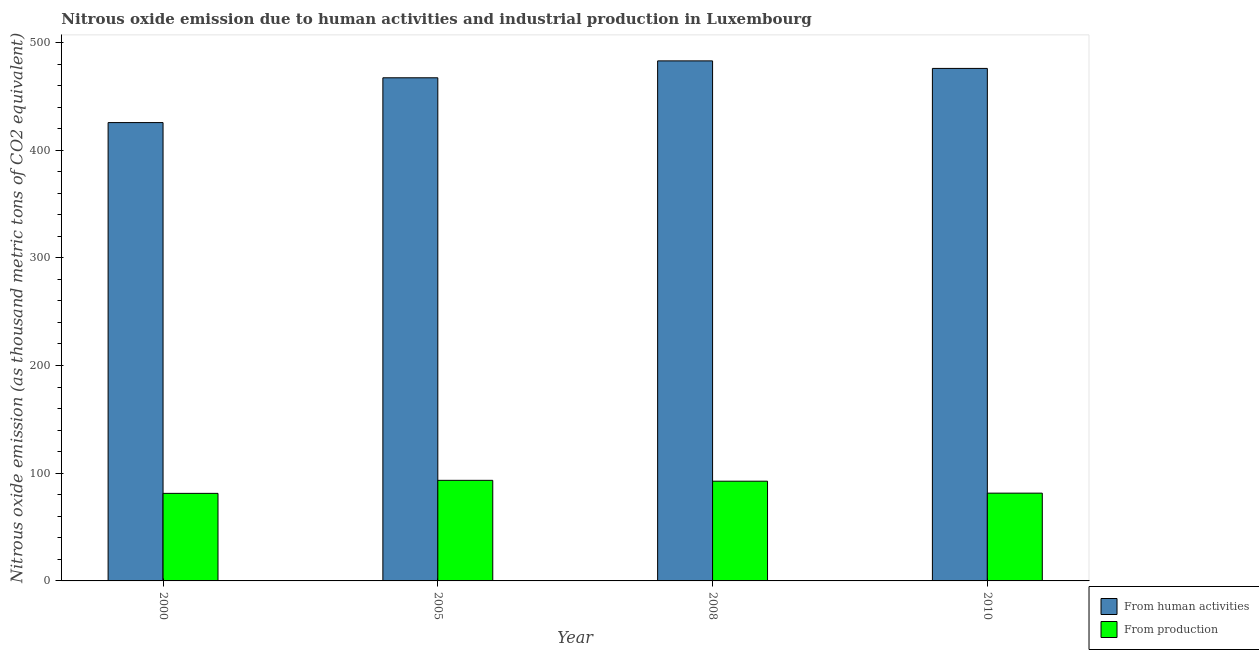How many groups of bars are there?
Provide a succinct answer. 4. How many bars are there on the 1st tick from the left?
Your answer should be very brief. 2. How many bars are there on the 1st tick from the right?
Your answer should be compact. 2. What is the label of the 1st group of bars from the left?
Give a very brief answer. 2000. In how many cases, is the number of bars for a given year not equal to the number of legend labels?
Your answer should be compact. 0. What is the amount of emissions generated from industries in 2005?
Provide a short and direct response. 93.4. Across all years, what is the maximum amount of emissions from human activities?
Your answer should be very brief. 482.9. Across all years, what is the minimum amount of emissions generated from industries?
Provide a succinct answer. 81.3. What is the total amount of emissions from human activities in the graph?
Offer a very short reply. 1851.6. What is the difference between the amount of emissions from human activities in 2000 and that in 2010?
Offer a very short reply. -50.3. What is the average amount of emissions generated from industries per year?
Make the answer very short. 87.2. What is the ratio of the amount of emissions generated from industries in 2008 to that in 2010?
Provide a short and direct response. 1.14. Is the amount of emissions from human activities in 2000 less than that in 2008?
Provide a short and direct response. Yes. Is the difference between the amount of emissions generated from industries in 2005 and 2008 greater than the difference between the amount of emissions from human activities in 2005 and 2008?
Ensure brevity in your answer.  No. What is the difference between the highest and the lowest amount of emissions generated from industries?
Offer a terse response. 12.1. What does the 2nd bar from the left in 2005 represents?
Keep it short and to the point. From production. What does the 1st bar from the right in 2005 represents?
Offer a terse response. From production. How many years are there in the graph?
Your response must be concise. 4. Are the values on the major ticks of Y-axis written in scientific E-notation?
Make the answer very short. No. Does the graph contain grids?
Offer a terse response. No. What is the title of the graph?
Offer a very short reply. Nitrous oxide emission due to human activities and industrial production in Luxembourg. What is the label or title of the X-axis?
Your response must be concise. Year. What is the label or title of the Y-axis?
Give a very brief answer. Nitrous oxide emission (as thousand metric tons of CO2 equivalent). What is the Nitrous oxide emission (as thousand metric tons of CO2 equivalent) in From human activities in 2000?
Your answer should be compact. 425.6. What is the Nitrous oxide emission (as thousand metric tons of CO2 equivalent) of From production in 2000?
Offer a very short reply. 81.3. What is the Nitrous oxide emission (as thousand metric tons of CO2 equivalent) in From human activities in 2005?
Your answer should be compact. 467.2. What is the Nitrous oxide emission (as thousand metric tons of CO2 equivalent) in From production in 2005?
Offer a terse response. 93.4. What is the Nitrous oxide emission (as thousand metric tons of CO2 equivalent) of From human activities in 2008?
Provide a succinct answer. 482.9. What is the Nitrous oxide emission (as thousand metric tons of CO2 equivalent) of From production in 2008?
Offer a very short reply. 92.6. What is the Nitrous oxide emission (as thousand metric tons of CO2 equivalent) in From human activities in 2010?
Offer a very short reply. 475.9. What is the Nitrous oxide emission (as thousand metric tons of CO2 equivalent) in From production in 2010?
Provide a short and direct response. 81.5. Across all years, what is the maximum Nitrous oxide emission (as thousand metric tons of CO2 equivalent) in From human activities?
Your response must be concise. 482.9. Across all years, what is the maximum Nitrous oxide emission (as thousand metric tons of CO2 equivalent) in From production?
Provide a short and direct response. 93.4. Across all years, what is the minimum Nitrous oxide emission (as thousand metric tons of CO2 equivalent) of From human activities?
Your response must be concise. 425.6. Across all years, what is the minimum Nitrous oxide emission (as thousand metric tons of CO2 equivalent) of From production?
Provide a succinct answer. 81.3. What is the total Nitrous oxide emission (as thousand metric tons of CO2 equivalent) of From human activities in the graph?
Your response must be concise. 1851.6. What is the total Nitrous oxide emission (as thousand metric tons of CO2 equivalent) of From production in the graph?
Offer a very short reply. 348.8. What is the difference between the Nitrous oxide emission (as thousand metric tons of CO2 equivalent) of From human activities in 2000 and that in 2005?
Offer a terse response. -41.6. What is the difference between the Nitrous oxide emission (as thousand metric tons of CO2 equivalent) in From human activities in 2000 and that in 2008?
Your answer should be compact. -57.3. What is the difference between the Nitrous oxide emission (as thousand metric tons of CO2 equivalent) of From production in 2000 and that in 2008?
Give a very brief answer. -11.3. What is the difference between the Nitrous oxide emission (as thousand metric tons of CO2 equivalent) of From human activities in 2000 and that in 2010?
Keep it short and to the point. -50.3. What is the difference between the Nitrous oxide emission (as thousand metric tons of CO2 equivalent) of From human activities in 2005 and that in 2008?
Provide a succinct answer. -15.7. What is the difference between the Nitrous oxide emission (as thousand metric tons of CO2 equivalent) of From production in 2005 and that in 2008?
Your response must be concise. 0.8. What is the difference between the Nitrous oxide emission (as thousand metric tons of CO2 equivalent) in From human activities in 2005 and that in 2010?
Offer a very short reply. -8.7. What is the difference between the Nitrous oxide emission (as thousand metric tons of CO2 equivalent) of From production in 2005 and that in 2010?
Keep it short and to the point. 11.9. What is the difference between the Nitrous oxide emission (as thousand metric tons of CO2 equivalent) in From human activities in 2008 and that in 2010?
Provide a short and direct response. 7. What is the difference between the Nitrous oxide emission (as thousand metric tons of CO2 equivalent) in From human activities in 2000 and the Nitrous oxide emission (as thousand metric tons of CO2 equivalent) in From production in 2005?
Give a very brief answer. 332.2. What is the difference between the Nitrous oxide emission (as thousand metric tons of CO2 equivalent) in From human activities in 2000 and the Nitrous oxide emission (as thousand metric tons of CO2 equivalent) in From production in 2008?
Provide a short and direct response. 333. What is the difference between the Nitrous oxide emission (as thousand metric tons of CO2 equivalent) in From human activities in 2000 and the Nitrous oxide emission (as thousand metric tons of CO2 equivalent) in From production in 2010?
Keep it short and to the point. 344.1. What is the difference between the Nitrous oxide emission (as thousand metric tons of CO2 equivalent) of From human activities in 2005 and the Nitrous oxide emission (as thousand metric tons of CO2 equivalent) of From production in 2008?
Make the answer very short. 374.6. What is the difference between the Nitrous oxide emission (as thousand metric tons of CO2 equivalent) of From human activities in 2005 and the Nitrous oxide emission (as thousand metric tons of CO2 equivalent) of From production in 2010?
Provide a short and direct response. 385.7. What is the difference between the Nitrous oxide emission (as thousand metric tons of CO2 equivalent) of From human activities in 2008 and the Nitrous oxide emission (as thousand metric tons of CO2 equivalent) of From production in 2010?
Make the answer very short. 401.4. What is the average Nitrous oxide emission (as thousand metric tons of CO2 equivalent) of From human activities per year?
Offer a terse response. 462.9. What is the average Nitrous oxide emission (as thousand metric tons of CO2 equivalent) of From production per year?
Your answer should be compact. 87.2. In the year 2000, what is the difference between the Nitrous oxide emission (as thousand metric tons of CO2 equivalent) in From human activities and Nitrous oxide emission (as thousand metric tons of CO2 equivalent) in From production?
Offer a terse response. 344.3. In the year 2005, what is the difference between the Nitrous oxide emission (as thousand metric tons of CO2 equivalent) in From human activities and Nitrous oxide emission (as thousand metric tons of CO2 equivalent) in From production?
Keep it short and to the point. 373.8. In the year 2008, what is the difference between the Nitrous oxide emission (as thousand metric tons of CO2 equivalent) in From human activities and Nitrous oxide emission (as thousand metric tons of CO2 equivalent) in From production?
Give a very brief answer. 390.3. In the year 2010, what is the difference between the Nitrous oxide emission (as thousand metric tons of CO2 equivalent) of From human activities and Nitrous oxide emission (as thousand metric tons of CO2 equivalent) of From production?
Offer a very short reply. 394.4. What is the ratio of the Nitrous oxide emission (as thousand metric tons of CO2 equivalent) in From human activities in 2000 to that in 2005?
Ensure brevity in your answer.  0.91. What is the ratio of the Nitrous oxide emission (as thousand metric tons of CO2 equivalent) in From production in 2000 to that in 2005?
Your answer should be compact. 0.87. What is the ratio of the Nitrous oxide emission (as thousand metric tons of CO2 equivalent) of From human activities in 2000 to that in 2008?
Make the answer very short. 0.88. What is the ratio of the Nitrous oxide emission (as thousand metric tons of CO2 equivalent) of From production in 2000 to that in 2008?
Offer a terse response. 0.88. What is the ratio of the Nitrous oxide emission (as thousand metric tons of CO2 equivalent) in From human activities in 2000 to that in 2010?
Provide a succinct answer. 0.89. What is the ratio of the Nitrous oxide emission (as thousand metric tons of CO2 equivalent) in From production in 2000 to that in 2010?
Ensure brevity in your answer.  1. What is the ratio of the Nitrous oxide emission (as thousand metric tons of CO2 equivalent) in From human activities in 2005 to that in 2008?
Give a very brief answer. 0.97. What is the ratio of the Nitrous oxide emission (as thousand metric tons of CO2 equivalent) in From production in 2005 to that in 2008?
Give a very brief answer. 1.01. What is the ratio of the Nitrous oxide emission (as thousand metric tons of CO2 equivalent) in From human activities in 2005 to that in 2010?
Make the answer very short. 0.98. What is the ratio of the Nitrous oxide emission (as thousand metric tons of CO2 equivalent) in From production in 2005 to that in 2010?
Offer a very short reply. 1.15. What is the ratio of the Nitrous oxide emission (as thousand metric tons of CO2 equivalent) of From human activities in 2008 to that in 2010?
Give a very brief answer. 1.01. What is the ratio of the Nitrous oxide emission (as thousand metric tons of CO2 equivalent) of From production in 2008 to that in 2010?
Give a very brief answer. 1.14. What is the difference between the highest and the lowest Nitrous oxide emission (as thousand metric tons of CO2 equivalent) of From human activities?
Ensure brevity in your answer.  57.3. 